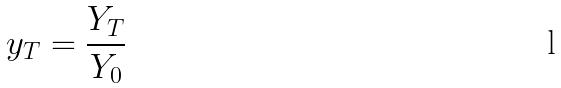Convert formula to latex. <formula><loc_0><loc_0><loc_500><loc_500>y _ { T } = \frac { Y _ { T } } { Y _ { 0 } }</formula> 